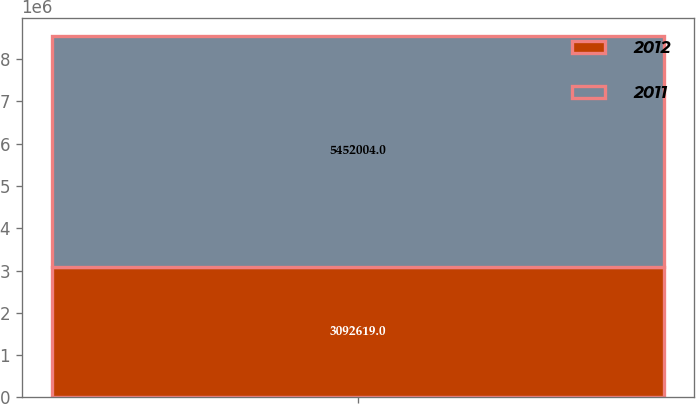Convert chart to OTSL. <chart><loc_0><loc_0><loc_500><loc_500><stacked_bar_chart><ecel><fcel>Unnamed: 1<nl><fcel>2012<fcel>3.09262e+06<nl><fcel>2011<fcel>5.452e+06<nl></chart> 